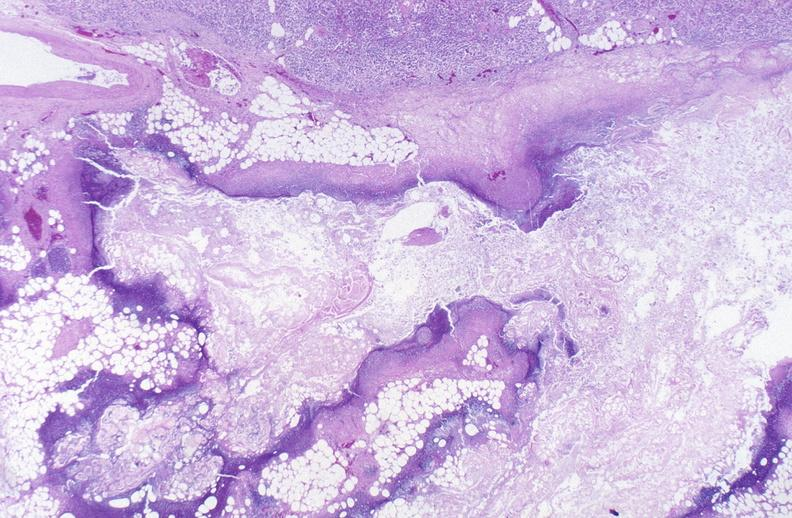does brain, cryptococcal meningitis, pas show pancreatic fat necrosis?
Answer the question using a single word or phrase. No 